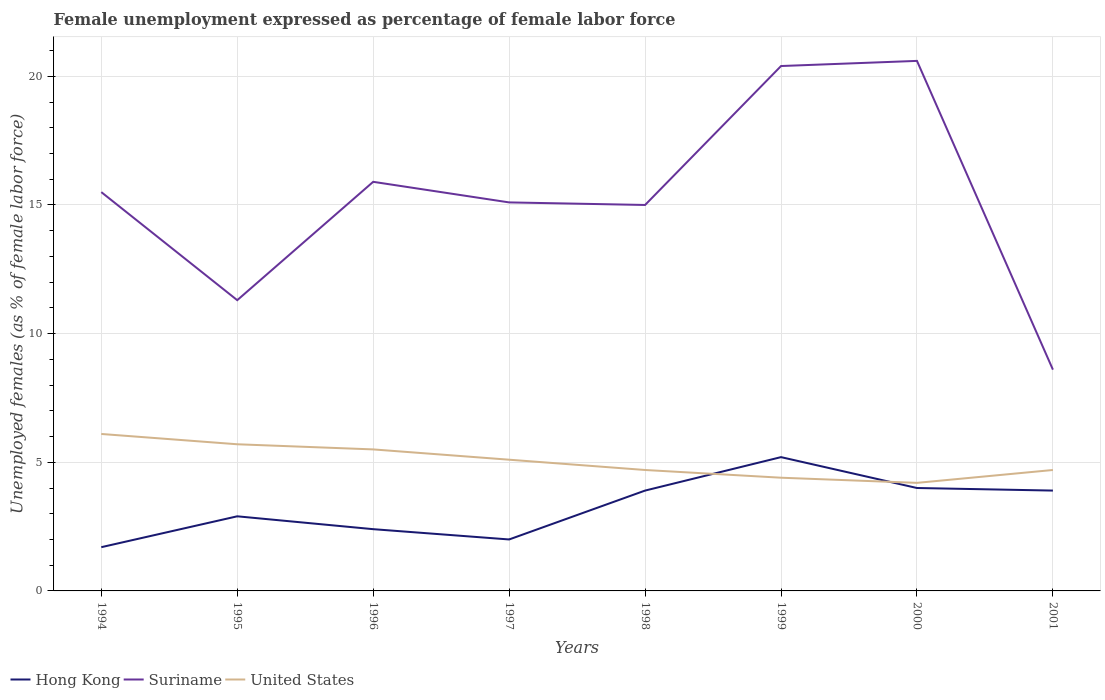Is the number of lines equal to the number of legend labels?
Provide a succinct answer. Yes. Across all years, what is the maximum unemployment in females in in Suriname?
Keep it short and to the point. 8.6. In which year was the unemployment in females in in Suriname maximum?
Make the answer very short. 2001. What is the total unemployment in females in in United States in the graph?
Ensure brevity in your answer.  0.4. What is the difference between the highest and the second highest unemployment in females in in United States?
Your response must be concise. 1.9. Are the values on the major ticks of Y-axis written in scientific E-notation?
Keep it short and to the point. No. How many legend labels are there?
Make the answer very short. 3. How are the legend labels stacked?
Offer a very short reply. Horizontal. What is the title of the graph?
Provide a short and direct response. Female unemployment expressed as percentage of female labor force. What is the label or title of the X-axis?
Your answer should be compact. Years. What is the label or title of the Y-axis?
Provide a succinct answer. Unemployed females (as % of female labor force). What is the Unemployed females (as % of female labor force) of Hong Kong in 1994?
Give a very brief answer. 1.7. What is the Unemployed females (as % of female labor force) in United States in 1994?
Offer a very short reply. 6.1. What is the Unemployed females (as % of female labor force) of Hong Kong in 1995?
Give a very brief answer. 2.9. What is the Unemployed females (as % of female labor force) in Suriname in 1995?
Provide a succinct answer. 11.3. What is the Unemployed females (as % of female labor force) of United States in 1995?
Make the answer very short. 5.7. What is the Unemployed females (as % of female labor force) in Hong Kong in 1996?
Offer a very short reply. 2.4. What is the Unemployed females (as % of female labor force) of Suriname in 1996?
Provide a succinct answer. 15.9. What is the Unemployed females (as % of female labor force) of Suriname in 1997?
Offer a terse response. 15.1. What is the Unemployed females (as % of female labor force) in United States in 1997?
Give a very brief answer. 5.1. What is the Unemployed females (as % of female labor force) of Hong Kong in 1998?
Your answer should be compact. 3.9. What is the Unemployed females (as % of female labor force) of United States in 1998?
Make the answer very short. 4.7. What is the Unemployed females (as % of female labor force) in Hong Kong in 1999?
Your answer should be compact. 5.2. What is the Unemployed females (as % of female labor force) in Suriname in 1999?
Keep it short and to the point. 20.4. What is the Unemployed females (as % of female labor force) in United States in 1999?
Give a very brief answer. 4.4. What is the Unemployed females (as % of female labor force) of Hong Kong in 2000?
Give a very brief answer. 4. What is the Unemployed females (as % of female labor force) in Suriname in 2000?
Provide a succinct answer. 20.6. What is the Unemployed females (as % of female labor force) in United States in 2000?
Offer a terse response. 4.2. What is the Unemployed females (as % of female labor force) in Hong Kong in 2001?
Keep it short and to the point. 3.9. What is the Unemployed females (as % of female labor force) in Suriname in 2001?
Make the answer very short. 8.6. What is the Unemployed females (as % of female labor force) of United States in 2001?
Provide a succinct answer. 4.7. Across all years, what is the maximum Unemployed females (as % of female labor force) of Hong Kong?
Ensure brevity in your answer.  5.2. Across all years, what is the maximum Unemployed females (as % of female labor force) of Suriname?
Give a very brief answer. 20.6. Across all years, what is the maximum Unemployed females (as % of female labor force) in United States?
Provide a short and direct response. 6.1. Across all years, what is the minimum Unemployed females (as % of female labor force) of Hong Kong?
Keep it short and to the point. 1.7. Across all years, what is the minimum Unemployed females (as % of female labor force) in Suriname?
Your answer should be very brief. 8.6. Across all years, what is the minimum Unemployed females (as % of female labor force) of United States?
Provide a succinct answer. 4.2. What is the total Unemployed females (as % of female labor force) in Suriname in the graph?
Your answer should be compact. 122.4. What is the total Unemployed females (as % of female labor force) in United States in the graph?
Ensure brevity in your answer.  40.4. What is the difference between the Unemployed females (as % of female labor force) of Hong Kong in 1994 and that in 1995?
Give a very brief answer. -1.2. What is the difference between the Unemployed females (as % of female labor force) in Hong Kong in 1994 and that in 1996?
Give a very brief answer. -0.7. What is the difference between the Unemployed females (as % of female labor force) in Hong Kong in 1994 and that in 1997?
Keep it short and to the point. -0.3. What is the difference between the Unemployed females (as % of female labor force) in Hong Kong in 1994 and that in 1998?
Offer a very short reply. -2.2. What is the difference between the Unemployed females (as % of female labor force) of Suriname in 1994 and that in 1998?
Provide a short and direct response. 0.5. What is the difference between the Unemployed females (as % of female labor force) in United States in 1994 and that in 1998?
Your response must be concise. 1.4. What is the difference between the Unemployed females (as % of female labor force) of Hong Kong in 1994 and that in 1999?
Your answer should be compact. -3.5. What is the difference between the Unemployed females (as % of female labor force) of Suriname in 1994 and that in 1999?
Your answer should be very brief. -4.9. What is the difference between the Unemployed females (as % of female labor force) of Suriname in 1994 and that in 2000?
Your response must be concise. -5.1. What is the difference between the Unemployed females (as % of female labor force) of Suriname in 1994 and that in 2001?
Your answer should be compact. 6.9. What is the difference between the Unemployed females (as % of female labor force) of United States in 1994 and that in 2001?
Your response must be concise. 1.4. What is the difference between the Unemployed females (as % of female labor force) in Hong Kong in 1995 and that in 1996?
Keep it short and to the point. 0.5. What is the difference between the Unemployed females (as % of female labor force) of United States in 1995 and that in 1996?
Provide a succinct answer. 0.2. What is the difference between the Unemployed females (as % of female labor force) of Suriname in 1995 and that in 1997?
Make the answer very short. -3.8. What is the difference between the Unemployed females (as % of female labor force) of United States in 1995 and that in 1997?
Offer a very short reply. 0.6. What is the difference between the Unemployed females (as % of female labor force) in Hong Kong in 1995 and that in 1998?
Make the answer very short. -1. What is the difference between the Unemployed females (as % of female labor force) of Suriname in 1995 and that in 1998?
Offer a terse response. -3.7. What is the difference between the Unemployed females (as % of female labor force) in Hong Kong in 1995 and that in 1999?
Offer a very short reply. -2.3. What is the difference between the Unemployed females (as % of female labor force) of Hong Kong in 1995 and that in 2000?
Your answer should be very brief. -1.1. What is the difference between the Unemployed females (as % of female labor force) in Suriname in 1995 and that in 2000?
Keep it short and to the point. -9.3. What is the difference between the Unemployed females (as % of female labor force) of United States in 1995 and that in 2000?
Offer a very short reply. 1.5. What is the difference between the Unemployed females (as % of female labor force) of Hong Kong in 1995 and that in 2001?
Provide a short and direct response. -1. What is the difference between the Unemployed females (as % of female labor force) in Suriname in 1995 and that in 2001?
Offer a very short reply. 2.7. What is the difference between the Unemployed females (as % of female labor force) in United States in 1996 and that in 1997?
Offer a very short reply. 0.4. What is the difference between the Unemployed females (as % of female labor force) in Suriname in 1996 and that in 1998?
Your response must be concise. 0.9. What is the difference between the Unemployed females (as % of female labor force) in Hong Kong in 1996 and that in 1999?
Offer a terse response. -2.8. What is the difference between the Unemployed females (as % of female labor force) in Suriname in 1996 and that in 1999?
Ensure brevity in your answer.  -4.5. What is the difference between the Unemployed females (as % of female labor force) of United States in 1996 and that in 1999?
Make the answer very short. 1.1. What is the difference between the Unemployed females (as % of female labor force) in Hong Kong in 1996 and that in 2000?
Provide a succinct answer. -1.6. What is the difference between the Unemployed females (as % of female labor force) in United States in 1996 and that in 2000?
Keep it short and to the point. 1.3. What is the difference between the Unemployed females (as % of female labor force) in United States in 1997 and that in 1998?
Keep it short and to the point. 0.4. What is the difference between the Unemployed females (as % of female labor force) in Suriname in 1997 and that in 1999?
Your response must be concise. -5.3. What is the difference between the Unemployed females (as % of female labor force) of United States in 1997 and that in 1999?
Your response must be concise. 0.7. What is the difference between the Unemployed females (as % of female labor force) in Hong Kong in 1997 and that in 2000?
Offer a terse response. -2. What is the difference between the Unemployed females (as % of female labor force) in Suriname in 1997 and that in 2000?
Give a very brief answer. -5.5. What is the difference between the Unemployed females (as % of female labor force) in Hong Kong in 1997 and that in 2001?
Keep it short and to the point. -1.9. What is the difference between the Unemployed females (as % of female labor force) in Suriname in 1997 and that in 2001?
Your answer should be very brief. 6.5. What is the difference between the Unemployed females (as % of female labor force) of Suriname in 1998 and that in 1999?
Ensure brevity in your answer.  -5.4. What is the difference between the Unemployed females (as % of female labor force) in United States in 1998 and that in 1999?
Keep it short and to the point. 0.3. What is the difference between the Unemployed females (as % of female labor force) of Hong Kong in 1998 and that in 2000?
Offer a terse response. -0.1. What is the difference between the Unemployed females (as % of female labor force) of United States in 1998 and that in 2000?
Provide a short and direct response. 0.5. What is the difference between the Unemployed females (as % of female labor force) of Hong Kong in 1999 and that in 2001?
Offer a very short reply. 1.3. What is the difference between the Unemployed females (as % of female labor force) of Suriname in 2000 and that in 2001?
Your answer should be compact. 12. What is the difference between the Unemployed females (as % of female labor force) of United States in 2000 and that in 2001?
Give a very brief answer. -0.5. What is the difference between the Unemployed females (as % of female labor force) of Hong Kong in 1994 and the Unemployed females (as % of female labor force) of Suriname in 1995?
Give a very brief answer. -9.6. What is the difference between the Unemployed females (as % of female labor force) in Suriname in 1994 and the Unemployed females (as % of female labor force) in United States in 1995?
Keep it short and to the point. 9.8. What is the difference between the Unemployed females (as % of female labor force) of Hong Kong in 1994 and the Unemployed females (as % of female labor force) of Suriname in 1996?
Offer a terse response. -14.2. What is the difference between the Unemployed females (as % of female labor force) in Hong Kong in 1994 and the Unemployed females (as % of female labor force) in United States in 1996?
Provide a short and direct response. -3.8. What is the difference between the Unemployed females (as % of female labor force) in Suriname in 1994 and the Unemployed females (as % of female labor force) in United States in 1996?
Make the answer very short. 10. What is the difference between the Unemployed females (as % of female labor force) in Hong Kong in 1994 and the Unemployed females (as % of female labor force) in United States in 1997?
Provide a succinct answer. -3.4. What is the difference between the Unemployed females (as % of female labor force) of Suriname in 1994 and the Unemployed females (as % of female labor force) of United States in 1997?
Offer a very short reply. 10.4. What is the difference between the Unemployed females (as % of female labor force) of Suriname in 1994 and the Unemployed females (as % of female labor force) of United States in 1998?
Your response must be concise. 10.8. What is the difference between the Unemployed females (as % of female labor force) of Hong Kong in 1994 and the Unemployed females (as % of female labor force) of Suriname in 1999?
Provide a short and direct response. -18.7. What is the difference between the Unemployed females (as % of female labor force) in Suriname in 1994 and the Unemployed females (as % of female labor force) in United States in 1999?
Offer a very short reply. 11.1. What is the difference between the Unemployed females (as % of female labor force) of Hong Kong in 1994 and the Unemployed females (as % of female labor force) of Suriname in 2000?
Keep it short and to the point. -18.9. What is the difference between the Unemployed females (as % of female labor force) in Hong Kong in 1994 and the Unemployed females (as % of female labor force) in United States in 2000?
Offer a very short reply. -2.5. What is the difference between the Unemployed females (as % of female labor force) in Suriname in 1994 and the Unemployed females (as % of female labor force) in United States in 2000?
Your answer should be compact. 11.3. What is the difference between the Unemployed females (as % of female labor force) in Hong Kong in 1994 and the Unemployed females (as % of female labor force) in United States in 2001?
Ensure brevity in your answer.  -3. What is the difference between the Unemployed females (as % of female labor force) in Suriname in 1994 and the Unemployed females (as % of female labor force) in United States in 2001?
Ensure brevity in your answer.  10.8. What is the difference between the Unemployed females (as % of female labor force) in Hong Kong in 1995 and the Unemployed females (as % of female labor force) in Suriname in 1996?
Give a very brief answer. -13. What is the difference between the Unemployed females (as % of female labor force) in Hong Kong in 1995 and the Unemployed females (as % of female labor force) in Suriname in 1997?
Offer a very short reply. -12.2. What is the difference between the Unemployed females (as % of female labor force) in Hong Kong in 1995 and the Unemployed females (as % of female labor force) in United States in 1997?
Provide a short and direct response. -2.2. What is the difference between the Unemployed females (as % of female labor force) in Hong Kong in 1995 and the Unemployed females (as % of female labor force) in Suriname in 1998?
Provide a succinct answer. -12.1. What is the difference between the Unemployed females (as % of female labor force) of Hong Kong in 1995 and the Unemployed females (as % of female labor force) of Suriname in 1999?
Your answer should be compact. -17.5. What is the difference between the Unemployed females (as % of female labor force) in Hong Kong in 1995 and the Unemployed females (as % of female labor force) in United States in 1999?
Provide a succinct answer. -1.5. What is the difference between the Unemployed females (as % of female labor force) of Hong Kong in 1995 and the Unemployed females (as % of female labor force) of Suriname in 2000?
Your answer should be very brief. -17.7. What is the difference between the Unemployed females (as % of female labor force) of Suriname in 1995 and the Unemployed females (as % of female labor force) of United States in 2000?
Provide a short and direct response. 7.1. What is the difference between the Unemployed females (as % of female labor force) of Hong Kong in 1996 and the Unemployed females (as % of female labor force) of Suriname in 1997?
Make the answer very short. -12.7. What is the difference between the Unemployed females (as % of female labor force) in Suriname in 1996 and the Unemployed females (as % of female labor force) in United States in 1997?
Provide a succinct answer. 10.8. What is the difference between the Unemployed females (as % of female labor force) in Hong Kong in 1996 and the Unemployed females (as % of female labor force) in United States in 1998?
Your answer should be compact. -2.3. What is the difference between the Unemployed females (as % of female labor force) of Suriname in 1996 and the Unemployed females (as % of female labor force) of United States in 1999?
Keep it short and to the point. 11.5. What is the difference between the Unemployed females (as % of female labor force) of Hong Kong in 1996 and the Unemployed females (as % of female labor force) of Suriname in 2000?
Ensure brevity in your answer.  -18.2. What is the difference between the Unemployed females (as % of female labor force) in Hong Kong in 1996 and the Unemployed females (as % of female labor force) in United States in 2001?
Offer a very short reply. -2.3. What is the difference between the Unemployed females (as % of female labor force) of Suriname in 1996 and the Unemployed females (as % of female labor force) of United States in 2001?
Provide a succinct answer. 11.2. What is the difference between the Unemployed females (as % of female labor force) in Suriname in 1997 and the Unemployed females (as % of female labor force) in United States in 1998?
Give a very brief answer. 10.4. What is the difference between the Unemployed females (as % of female labor force) in Hong Kong in 1997 and the Unemployed females (as % of female labor force) in Suriname in 1999?
Provide a short and direct response. -18.4. What is the difference between the Unemployed females (as % of female labor force) in Hong Kong in 1997 and the Unemployed females (as % of female labor force) in United States in 1999?
Keep it short and to the point. -2.4. What is the difference between the Unemployed females (as % of female labor force) of Hong Kong in 1997 and the Unemployed females (as % of female labor force) of Suriname in 2000?
Your response must be concise. -18.6. What is the difference between the Unemployed females (as % of female labor force) of Suriname in 1997 and the Unemployed females (as % of female labor force) of United States in 2000?
Keep it short and to the point. 10.9. What is the difference between the Unemployed females (as % of female labor force) in Hong Kong in 1997 and the Unemployed females (as % of female labor force) in Suriname in 2001?
Your answer should be very brief. -6.6. What is the difference between the Unemployed females (as % of female labor force) of Hong Kong in 1997 and the Unemployed females (as % of female labor force) of United States in 2001?
Keep it short and to the point. -2.7. What is the difference between the Unemployed females (as % of female labor force) in Suriname in 1997 and the Unemployed females (as % of female labor force) in United States in 2001?
Your answer should be compact. 10.4. What is the difference between the Unemployed females (as % of female labor force) in Hong Kong in 1998 and the Unemployed females (as % of female labor force) in Suriname in 1999?
Offer a very short reply. -16.5. What is the difference between the Unemployed females (as % of female labor force) of Hong Kong in 1998 and the Unemployed females (as % of female labor force) of United States in 1999?
Provide a short and direct response. -0.5. What is the difference between the Unemployed females (as % of female labor force) in Hong Kong in 1998 and the Unemployed females (as % of female labor force) in Suriname in 2000?
Make the answer very short. -16.7. What is the difference between the Unemployed females (as % of female labor force) in Hong Kong in 1998 and the Unemployed females (as % of female labor force) in United States in 2000?
Your answer should be compact. -0.3. What is the difference between the Unemployed females (as % of female labor force) of Suriname in 1998 and the Unemployed females (as % of female labor force) of United States in 2000?
Make the answer very short. 10.8. What is the difference between the Unemployed females (as % of female labor force) of Hong Kong in 1998 and the Unemployed females (as % of female labor force) of United States in 2001?
Ensure brevity in your answer.  -0.8. What is the difference between the Unemployed females (as % of female labor force) in Hong Kong in 1999 and the Unemployed females (as % of female labor force) in Suriname in 2000?
Make the answer very short. -15.4. What is the difference between the Unemployed females (as % of female labor force) in Hong Kong in 1999 and the Unemployed females (as % of female labor force) in United States in 2001?
Your response must be concise. 0.5. What is the difference between the Unemployed females (as % of female labor force) of Suriname in 1999 and the Unemployed females (as % of female labor force) of United States in 2001?
Make the answer very short. 15.7. What is the difference between the Unemployed females (as % of female labor force) of Hong Kong in 2000 and the Unemployed females (as % of female labor force) of Suriname in 2001?
Keep it short and to the point. -4.6. What is the average Unemployed females (as % of female labor force) of Hong Kong per year?
Provide a short and direct response. 3.25. What is the average Unemployed females (as % of female labor force) of United States per year?
Ensure brevity in your answer.  5.05. In the year 1994, what is the difference between the Unemployed females (as % of female labor force) of Hong Kong and Unemployed females (as % of female labor force) of Suriname?
Your answer should be very brief. -13.8. In the year 1995, what is the difference between the Unemployed females (as % of female labor force) in Hong Kong and Unemployed females (as % of female labor force) in United States?
Your response must be concise. -2.8. In the year 1995, what is the difference between the Unemployed females (as % of female labor force) in Suriname and Unemployed females (as % of female labor force) in United States?
Your answer should be compact. 5.6. In the year 1996, what is the difference between the Unemployed females (as % of female labor force) of Hong Kong and Unemployed females (as % of female labor force) of Suriname?
Give a very brief answer. -13.5. In the year 1996, what is the difference between the Unemployed females (as % of female labor force) of Suriname and Unemployed females (as % of female labor force) of United States?
Provide a short and direct response. 10.4. In the year 1997, what is the difference between the Unemployed females (as % of female labor force) of Hong Kong and Unemployed females (as % of female labor force) of United States?
Your response must be concise. -3.1. In the year 1998, what is the difference between the Unemployed females (as % of female labor force) in Hong Kong and Unemployed females (as % of female labor force) in Suriname?
Your response must be concise. -11.1. In the year 1999, what is the difference between the Unemployed females (as % of female labor force) in Hong Kong and Unemployed females (as % of female labor force) in Suriname?
Ensure brevity in your answer.  -15.2. In the year 1999, what is the difference between the Unemployed females (as % of female labor force) of Hong Kong and Unemployed females (as % of female labor force) of United States?
Your response must be concise. 0.8. In the year 1999, what is the difference between the Unemployed females (as % of female labor force) in Suriname and Unemployed females (as % of female labor force) in United States?
Ensure brevity in your answer.  16. In the year 2000, what is the difference between the Unemployed females (as % of female labor force) in Hong Kong and Unemployed females (as % of female labor force) in Suriname?
Provide a short and direct response. -16.6. In the year 2000, what is the difference between the Unemployed females (as % of female labor force) of Hong Kong and Unemployed females (as % of female labor force) of United States?
Offer a terse response. -0.2. In the year 2000, what is the difference between the Unemployed females (as % of female labor force) in Suriname and Unemployed females (as % of female labor force) in United States?
Keep it short and to the point. 16.4. In the year 2001, what is the difference between the Unemployed females (as % of female labor force) in Hong Kong and Unemployed females (as % of female labor force) in Suriname?
Provide a short and direct response. -4.7. In the year 2001, what is the difference between the Unemployed females (as % of female labor force) of Hong Kong and Unemployed females (as % of female labor force) of United States?
Ensure brevity in your answer.  -0.8. What is the ratio of the Unemployed females (as % of female labor force) of Hong Kong in 1994 to that in 1995?
Make the answer very short. 0.59. What is the ratio of the Unemployed females (as % of female labor force) of Suriname in 1994 to that in 1995?
Make the answer very short. 1.37. What is the ratio of the Unemployed females (as % of female labor force) of United States in 1994 to that in 1995?
Your response must be concise. 1.07. What is the ratio of the Unemployed females (as % of female labor force) in Hong Kong in 1994 to that in 1996?
Make the answer very short. 0.71. What is the ratio of the Unemployed females (as % of female labor force) in Suriname in 1994 to that in 1996?
Your response must be concise. 0.97. What is the ratio of the Unemployed females (as % of female labor force) in United States in 1994 to that in 1996?
Provide a succinct answer. 1.11. What is the ratio of the Unemployed females (as % of female labor force) of Hong Kong in 1994 to that in 1997?
Your response must be concise. 0.85. What is the ratio of the Unemployed females (as % of female labor force) in Suriname in 1994 to that in 1997?
Give a very brief answer. 1.03. What is the ratio of the Unemployed females (as % of female labor force) in United States in 1994 to that in 1997?
Provide a short and direct response. 1.2. What is the ratio of the Unemployed females (as % of female labor force) in Hong Kong in 1994 to that in 1998?
Provide a short and direct response. 0.44. What is the ratio of the Unemployed females (as % of female labor force) of Suriname in 1994 to that in 1998?
Offer a very short reply. 1.03. What is the ratio of the Unemployed females (as % of female labor force) in United States in 1994 to that in 1998?
Provide a short and direct response. 1.3. What is the ratio of the Unemployed females (as % of female labor force) of Hong Kong in 1994 to that in 1999?
Keep it short and to the point. 0.33. What is the ratio of the Unemployed females (as % of female labor force) in Suriname in 1994 to that in 1999?
Keep it short and to the point. 0.76. What is the ratio of the Unemployed females (as % of female labor force) of United States in 1994 to that in 1999?
Provide a short and direct response. 1.39. What is the ratio of the Unemployed females (as % of female labor force) of Hong Kong in 1994 to that in 2000?
Give a very brief answer. 0.42. What is the ratio of the Unemployed females (as % of female labor force) in Suriname in 1994 to that in 2000?
Your response must be concise. 0.75. What is the ratio of the Unemployed females (as % of female labor force) of United States in 1994 to that in 2000?
Offer a terse response. 1.45. What is the ratio of the Unemployed females (as % of female labor force) in Hong Kong in 1994 to that in 2001?
Provide a succinct answer. 0.44. What is the ratio of the Unemployed females (as % of female labor force) in Suriname in 1994 to that in 2001?
Offer a very short reply. 1.8. What is the ratio of the Unemployed females (as % of female labor force) in United States in 1994 to that in 2001?
Your answer should be compact. 1.3. What is the ratio of the Unemployed females (as % of female labor force) in Hong Kong in 1995 to that in 1996?
Offer a terse response. 1.21. What is the ratio of the Unemployed females (as % of female labor force) of Suriname in 1995 to that in 1996?
Your answer should be very brief. 0.71. What is the ratio of the Unemployed females (as % of female labor force) of United States in 1995 to that in 1996?
Your response must be concise. 1.04. What is the ratio of the Unemployed females (as % of female labor force) of Hong Kong in 1995 to that in 1997?
Your answer should be very brief. 1.45. What is the ratio of the Unemployed females (as % of female labor force) in Suriname in 1995 to that in 1997?
Ensure brevity in your answer.  0.75. What is the ratio of the Unemployed females (as % of female labor force) in United States in 1995 to that in 1997?
Offer a very short reply. 1.12. What is the ratio of the Unemployed females (as % of female labor force) in Hong Kong in 1995 to that in 1998?
Make the answer very short. 0.74. What is the ratio of the Unemployed females (as % of female labor force) of Suriname in 1995 to that in 1998?
Your answer should be very brief. 0.75. What is the ratio of the Unemployed females (as % of female labor force) in United States in 1995 to that in 1998?
Give a very brief answer. 1.21. What is the ratio of the Unemployed females (as % of female labor force) in Hong Kong in 1995 to that in 1999?
Offer a very short reply. 0.56. What is the ratio of the Unemployed females (as % of female labor force) in Suriname in 1995 to that in 1999?
Keep it short and to the point. 0.55. What is the ratio of the Unemployed females (as % of female labor force) in United States in 1995 to that in 1999?
Make the answer very short. 1.3. What is the ratio of the Unemployed females (as % of female labor force) of Hong Kong in 1995 to that in 2000?
Make the answer very short. 0.72. What is the ratio of the Unemployed females (as % of female labor force) of Suriname in 1995 to that in 2000?
Make the answer very short. 0.55. What is the ratio of the Unemployed females (as % of female labor force) in United States in 1995 to that in 2000?
Your answer should be very brief. 1.36. What is the ratio of the Unemployed females (as % of female labor force) in Hong Kong in 1995 to that in 2001?
Offer a terse response. 0.74. What is the ratio of the Unemployed females (as % of female labor force) in Suriname in 1995 to that in 2001?
Your answer should be compact. 1.31. What is the ratio of the Unemployed females (as % of female labor force) in United States in 1995 to that in 2001?
Your response must be concise. 1.21. What is the ratio of the Unemployed females (as % of female labor force) of Suriname in 1996 to that in 1997?
Offer a very short reply. 1.05. What is the ratio of the Unemployed females (as % of female labor force) of United States in 1996 to that in 1997?
Give a very brief answer. 1.08. What is the ratio of the Unemployed females (as % of female labor force) in Hong Kong in 1996 to that in 1998?
Your response must be concise. 0.62. What is the ratio of the Unemployed females (as % of female labor force) in Suriname in 1996 to that in 1998?
Offer a very short reply. 1.06. What is the ratio of the Unemployed females (as % of female labor force) in United States in 1996 to that in 1998?
Provide a short and direct response. 1.17. What is the ratio of the Unemployed females (as % of female labor force) of Hong Kong in 1996 to that in 1999?
Provide a succinct answer. 0.46. What is the ratio of the Unemployed females (as % of female labor force) in Suriname in 1996 to that in 1999?
Offer a very short reply. 0.78. What is the ratio of the Unemployed females (as % of female labor force) of Hong Kong in 1996 to that in 2000?
Give a very brief answer. 0.6. What is the ratio of the Unemployed females (as % of female labor force) in Suriname in 1996 to that in 2000?
Provide a succinct answer. 0.77. What is the ratio of the Unemployed females (as % of female labor force) of United States in 1996 to that in 2000?
Keep it short and to the point. 1.31. What is the ratio of the Unemployed females (as % of female labor force) in Hong Kong in 1996 to that in 2001?
Your answer should be compact. 0.62. What is the ratio of the Unemployed females (as % of female labor force) of Suriname in 1996 to that in 2001?
Ensure brevity in your answer.  1.85. What is the ratio of the Unemployed females (as % of female labor force) of United States in 1996 to that in 2001?
Provide a short and direct response. 1.17. What is the ratio of the Unemployed females (as % of female labor force) of Hong Kong in 1997 to that in 1998?
Your answer should be compact. 0.51. What is the ratio of the Unemployed females (as % of female labor force) in Suriname in 1997 to that in 1998?
Keep it short and to the point. 1.01. What is the ratio of the Unemployed females (as % of female labor force) of United States in 1997 to that in 1998?
Ensure brevity in your answer.  1.09. What is the ratio of the Unemployed females (as % of female labor force) of Hong Kong in 1997 to that in 1999?
Offer a very short reply. 0.38. What is the ratio of the Unemployed females (as % of female labor force) in Suriname in 1997 to that in 1999?
Offer a very short reply. 0.74. What is the ratio of the Unemployed females (as % of female labor force) in United States in 1997 to that in 1999?
Offer a terse response. 1.16. What is the ratio of the Unemployed females (as % of female labor force) in Hong Kong in 1997 to that in 2000?
Offer a terse response. 0.5. What is the ratio of the Unemployed females (as % of female labor force) of Suriname in 1997 to that in 2000?
Your answer should be very brief. 0.73. What is the ratio of the Unemployed females (as % of female labor force) of United States in 1997 to that in 2000?
Make the answer very short. 1.21. What is the ratio of the Unemployed females (as % of female labor force) in Hong Kong in 1997 to that in 2001?
Ensure brevity in your answer.  0.51. What is the ratio of the Unemployed females (as % of female labor force) in Suriname in 1997 to that in 2001?
Your response must be concise. 1.76. What is the ratio of the Unemployed females (as % of female labor force) of United States in 1997 to that in 2001?
Ensure brevity in your answer.  1.09. What is the ratio of the Unemployed females (as % of female labor force) of Suriname in 1998 to that in 1999?
Keep it short and to the point. 0.74. What is the ratio of the Unemployed females (as % of female labor force) in United States in 1998 to that in 1999?
Make the answer very short. 1.07. What is the ratio of the Unemployed females (as % of female labor force) in Suriname in 1998 to that in 2000?
Offer a terse response. 0.73. What is the ratio of the Unemployed females (as % of female labor force) in United States in 1998 to that in 2000?
Provide a short and direct response. 1.12. What is the ratio of the Unemployed females (as % of female labor force) of Hong Kong in 1998 to that in 2001?
Give a very brief answer. 1. What is the ratio of the Unemployed females (as % of female labor force) in Suriname in 1998 to that in 2001?
Offer a terse response. 1.74. What is the ratio of the Unemployed females (as % of female labor force) in Hong Kong in 1999 to that in 2000?
Make the answer very short. 1.3. What is the ratio of the Unemployed females (as % of female labor force) of Suriname in 1999 to that in 2000?
Keep it short and to the point. 0.99. What is the ratio of the Unemployed females (as % of female labor force) of United States in 1999 to that in 2000?
Give a very brief answer. 1.05. What is the ratio of the Unemployed females (as % of female labor force) in Hong Kong in 1999 to that in 2001?
Your response must be concise. 1.33. What is the ratio of the Unemployed females (as % of female labor force) in Suriname in 1999 to that in 2001?
Offer a terse response. 2.37. What is the ratio of the Unemployed females (as % of female labor force) in United States in 1999 to that in 2001?
Offer a very short reply. 0.94. What is the ratio of the Unemployed females (as % of female labor force) of Hong Kong in 2000 to that in 2001?
Your answer should be very brief. 1.03. What is the ratio of the Unemployed females (as % of female labor force) of Suriname in 2000 to that in 2001?
Give a very brief answer. 2.4. What is the ratio of the Unemployed females (as % of female labor force) of United States in 2000 to that in 2001?
Provide a short and direct response. 0.89. What is the difference between the highest and the second highest Unemployed females (as % of female labor force) of Hong Kong?
Your response must be concise. 1.2. What is the difference between the highest and the second highest Unemployed females (as % of female labor force) of United States?
Give a very brief answer. 0.4. What is the difference between the highest and the lowest Unemployed females (as % of female labor force) in United States?
Your answer should be compact. 1.9. 